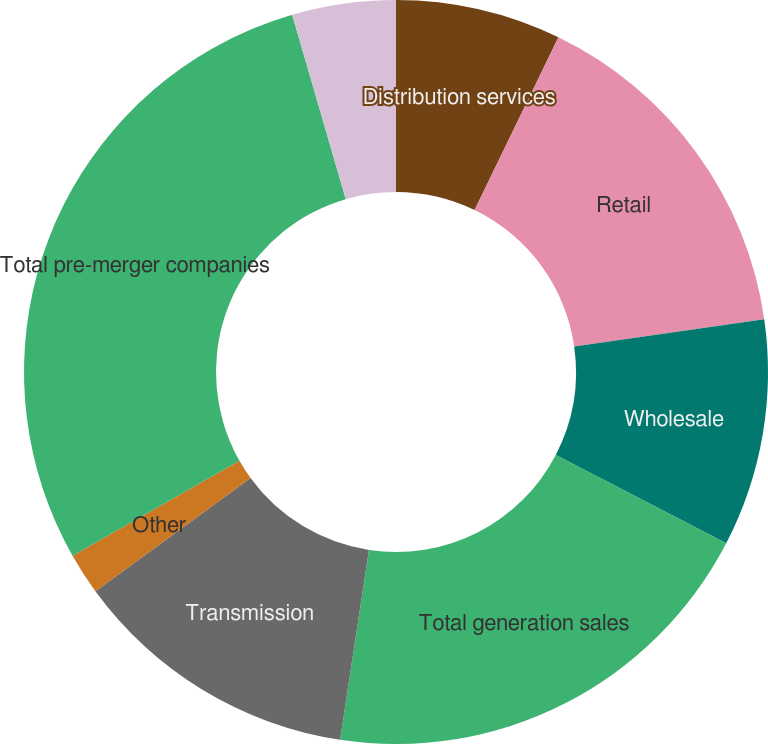Convert chart to OTSL. <chart><loc_0><loc_0><loc_500><loc_500><pie_chart><fcel>Distribution services<fcel>Retail<fcel>Wholesale<fcel>Total generation sales<fcel>Transmission<fcel>Other<fcel>Total pre-merger companies<fcel>Total Revenues<nl><fcel>7.19%<fcel>15.54%<fcel>9.88%<fcel>19.78%<fcel>12.57%<fcel>1.81%<fcel>28.71%<fcel>4.5%<nl></chart> 